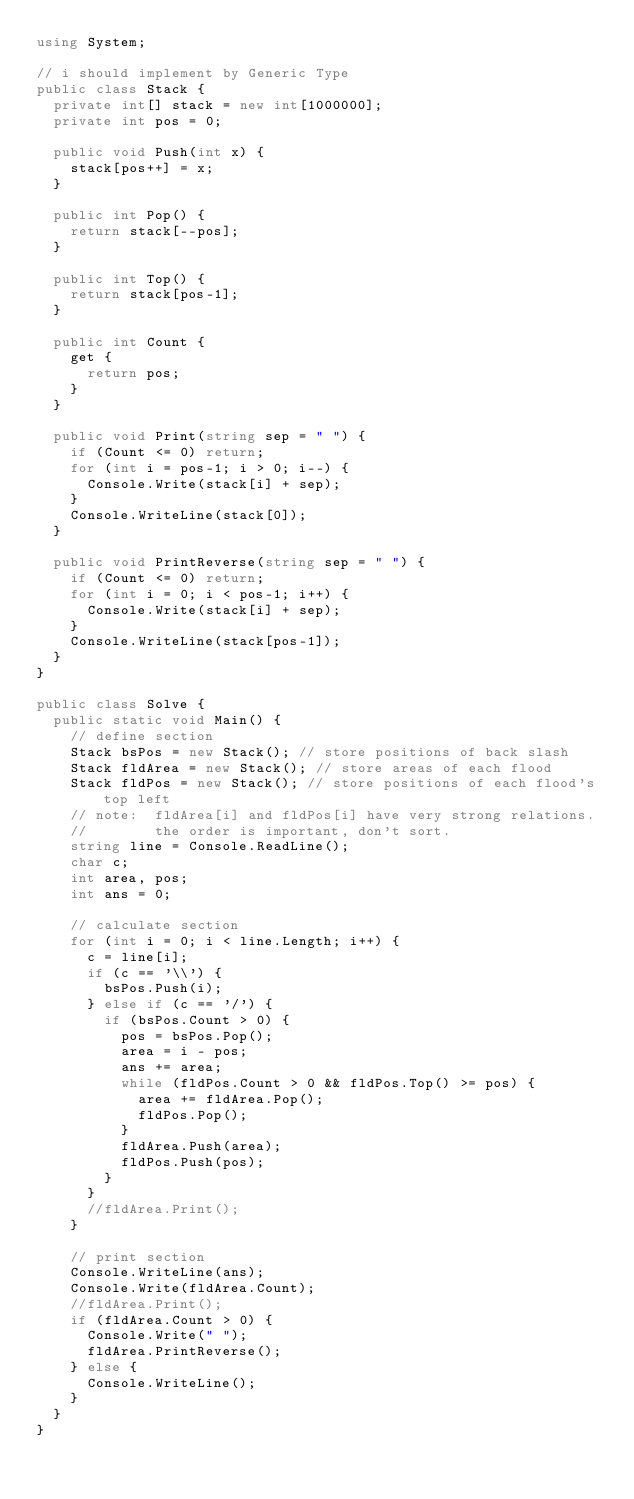Convert code to text. <code><loc_0><loc_0><loc_500><loc_500><_C#_>using System;

// i should implement by Generic Type
public class Stack {
  private int[] stack = new int[1000000];
  private int pos = 0;
  
  public void Push(int x) {
    stack[pos++] = x;
  }

  public int Pop() {
    return stack[--pos];
  }

  public int Top() {
    return stack[pos-1];
  }

  public int Count {
    get {
      return pos;
    }
  }

  public void Print(string sep = " ") {
    if (Count <= 0) return;
    for (int i = pos-1; i > 0; i--) {
      Console.Write(stack[i] + sep);
    }
    Console.WriteLine(stack[0]);
  }

  public void PrintReverse(string sep = " ") {
    if (Count <= 0) return;
    for (int i = 0; i < pos-1; i++) {
      Console.Write(stack[i] + sep);
    }
    Console.WriteLine(stack[pos-1]);
  }
}

public class Solve {
  public static void Main() {
    // define section
    Stack bsPos = new Stack(); // store positions of back slash  
    Stack fldArea = new Stack(); // store areas of each flood
    Stack fldPos = new Stack(); // store positions of each flood's top left
    // note:  fldArea[i] and fldPos[i] have very strong relations.
    //        the order is important, don't sort.
    string line = Console.ReadLine();
    char c;
    int area, pos;
    int ans = 0;
   
    // calculate section 
    for (int i = 0; i < line.Length; i++) {
      c = line[i];
      if (c == '\\') {
        bsPos.Push(i);
      } else if (c == '/') {
        if (bsPos.Count > 0) {
          pos = bsPos.Pop();
          area = i - pos;
          ans += area;
          while (fldPos.Count > 0 && fldPos.Top() >= pos) {
            area += fldArea.Pop();
            fldPos.Pop();  
          }
          fldArea.Push(area);
          fldPos.Push(pos);
        }
      }
      //fldArea.Print();
    }

    // print section
    Console.WriteLine(ans);
    Console.Write(fldArea.Count);
    //fldArea.Print();
    if (fldArea.Count > 0) {
      Console.Write(" ");
      fldArea.PrintReverse();
    } else {
      Console.WriteLine();
    }
  }
}


</code> 